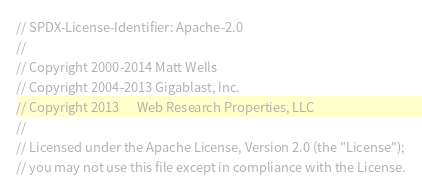<code> <loc_0><loc_0><loc_500><loc_500><_C++_>// SPDX-License-Identifier: Apache-2.0
//
// Copyright 2000-2014 Matt Wells
// Copyright 2004-2013 Gigablast, Inc.
// Copyright 2013      Web Research Properties, LLC
//
// Licensed under the Apache License, Version 2.0 (the "License");
// you may not use this file except in compliance with the License.</code> 